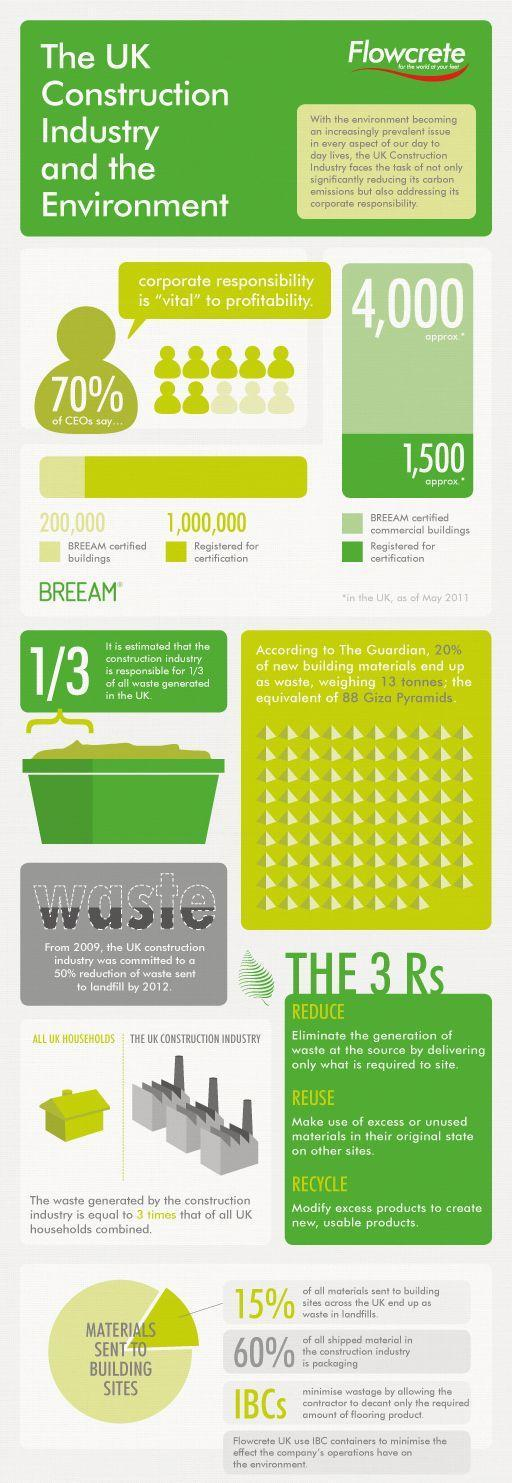Out of the 200,000 BREEAM certified buildings, how many are "non commercial" buildings?
Answer the question with a short phrase. 196000 Approximately how many "commercial"  buildings are registered for BREEAM certification? 1,500 Out of the total buildings in UK, how many are registered for BREEAM certification? 1,000,000 What are the 3 R's? Reduce, reuse, recycle Which industry produces thrice the waste produced in the the households (in UK)? Construction industry What percentage of raw materials used in the construction sites end up in landfills? 15% Out of the total buildings in UK, how many are BREEAM certified? 200,000 Approximately, how many "commercial"  buildings are BREEAM certified? 4,000 What percent of CEOs say that corporate responsibility is vital to profitability? 70% 